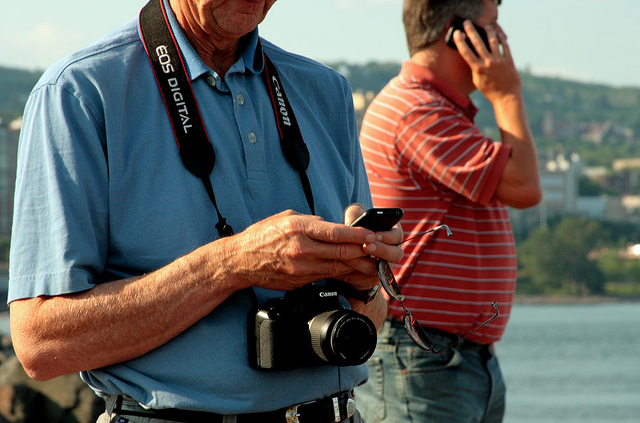What does the presence of another person in the background suggest about the location? The presence of another person engaged in a phone call suggests that the location is a public space where various activities are happening simultaneously. It's likely a place where individuals feel comfortable engaging in leisure activities like photography and social calls, perhaps a park, a promenade, or a tourist spot. What is the possible era or time period indicated by the technology being used? The design of the camera and the mobile phone indicates a time period that isn't the latest but also not too far in the past. This type of camera and mobile phone points to the early 2000s up until the early 2010s, a time when smartphones were not yet ubiquitous and dedicated digital cameras were common for photography enthusiasts. 